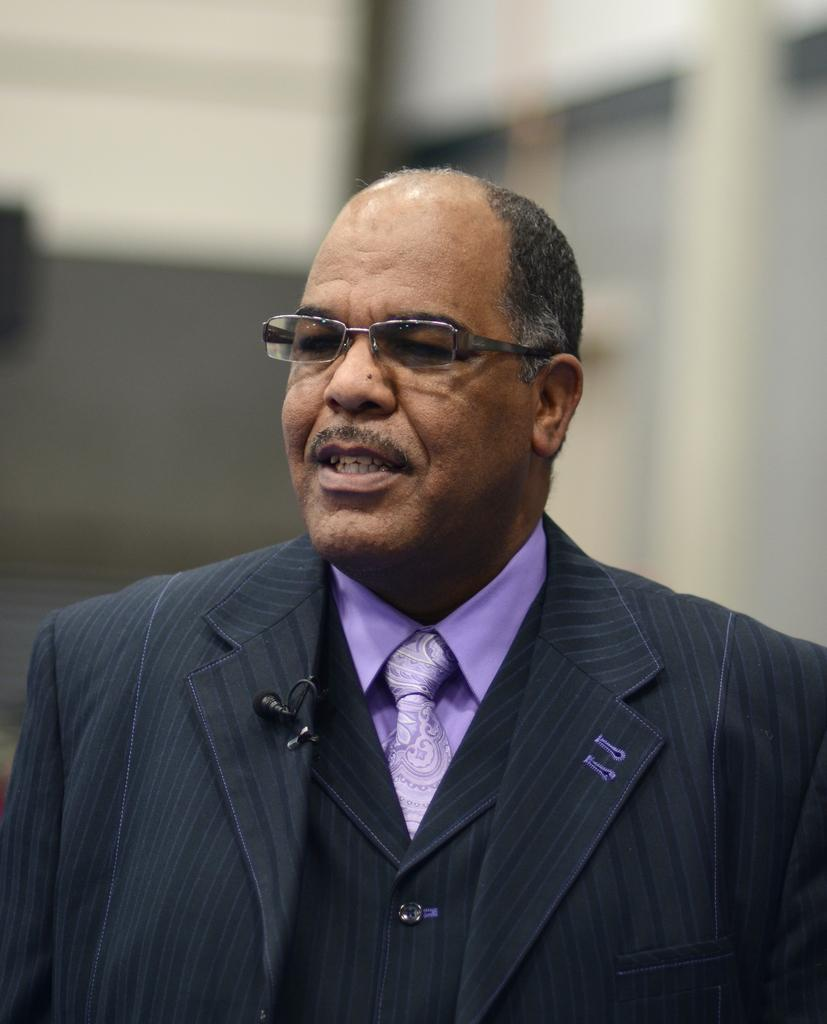What is the main subject of the image? The main subject of the image is a man. What is the man wearing in the image? The man is wearing a blazer in the image. How is the background of the man depicted in the image? The background of the man is blurred in the image. Who is the owner of the bag in the image? There is no bag present in the image, so it is not possible to determine the owner. 